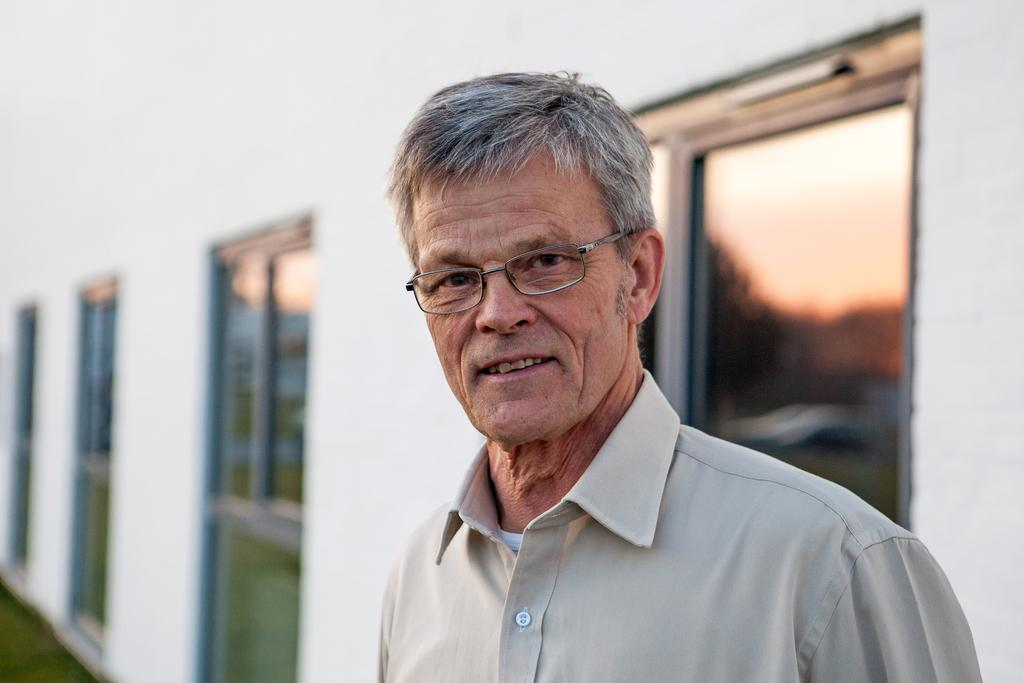Who is the main subject in the image? There is an old man in the image. What is the old man wearing? The old man is wearing glasses. What is the old man doing in the image? The old man is looking at something. What can be seen in the background of the image? There is a wall and windows in the background of the image. Where is the cemetery located in the image? There is no cemetery present in the image. What type of flame can be seen near the old man in the image? There is no flame present in the image. 